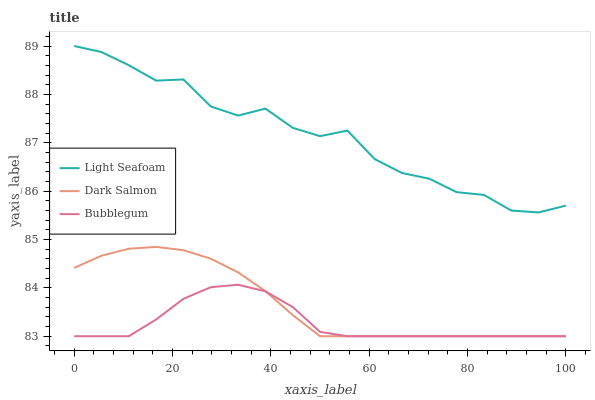Does Bubblegum have the minimum area under the curve?
Answer yes or no. Yes. Does Light Seafoam have the maximum area under the curve?
Answer yes or no. Yes. Does Dark Salmon have the minimum area under the curve?
Answer yes or no. No. Does Dark Salmon have the maximum area under the curve?
Answer yes or no. No. Is Dark Salmon the smoothest?
Answer yes or no. Yes. Is Light Seafoam the roughest?
Answer yes or no. Yes. Is Bubblegum the smoothest?
Answer yes or no. No. Is Bubblegum the roughest?
Answer yes or no. No. Does Dark Salmon have the lowest value?
Answer yes or no. Yes. Does Light Seafoam have the highest value?
Answer yes or no. Yes. Does Dark Salmon have the highest value?
Answer yes or no. No. Is Bubblegum less than Light Seafoam?
Answer yes or no. Yes. Is Light Seafoam greater than Bubblegum?
Answer yes or no. Yes. Does Bubblegum intersect Dark Salmon?
Answer yes or no. Yes. Is Bubblegum less than Dark Salmon?
Answer yes or no. No. Is Bubblegum greater than Dark Salmon?
Answer yes or no. No. Does Bubblegum intersect Light Seafoam?
Answer yes or no. No. 